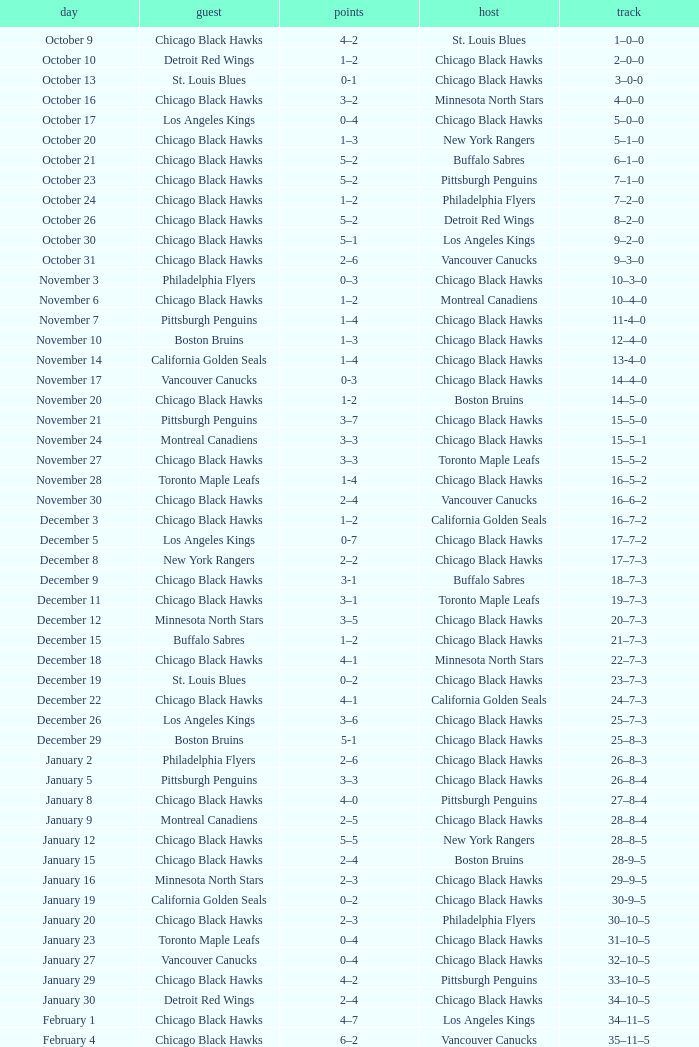What is the february 26 date's record? 39–16–7. 